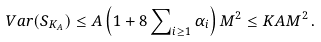<formula> <loc_0><loc_0><loc_500><loc_500>V a r ( S _ { K _ { A } } ) \leq A \left ( 1 + 8 \sum \nolimits _ { i \geq 1 } \alpha _ { i } \right ) M ^ { 2 } \leq K A M ^ { 2 } \, .</formula> 